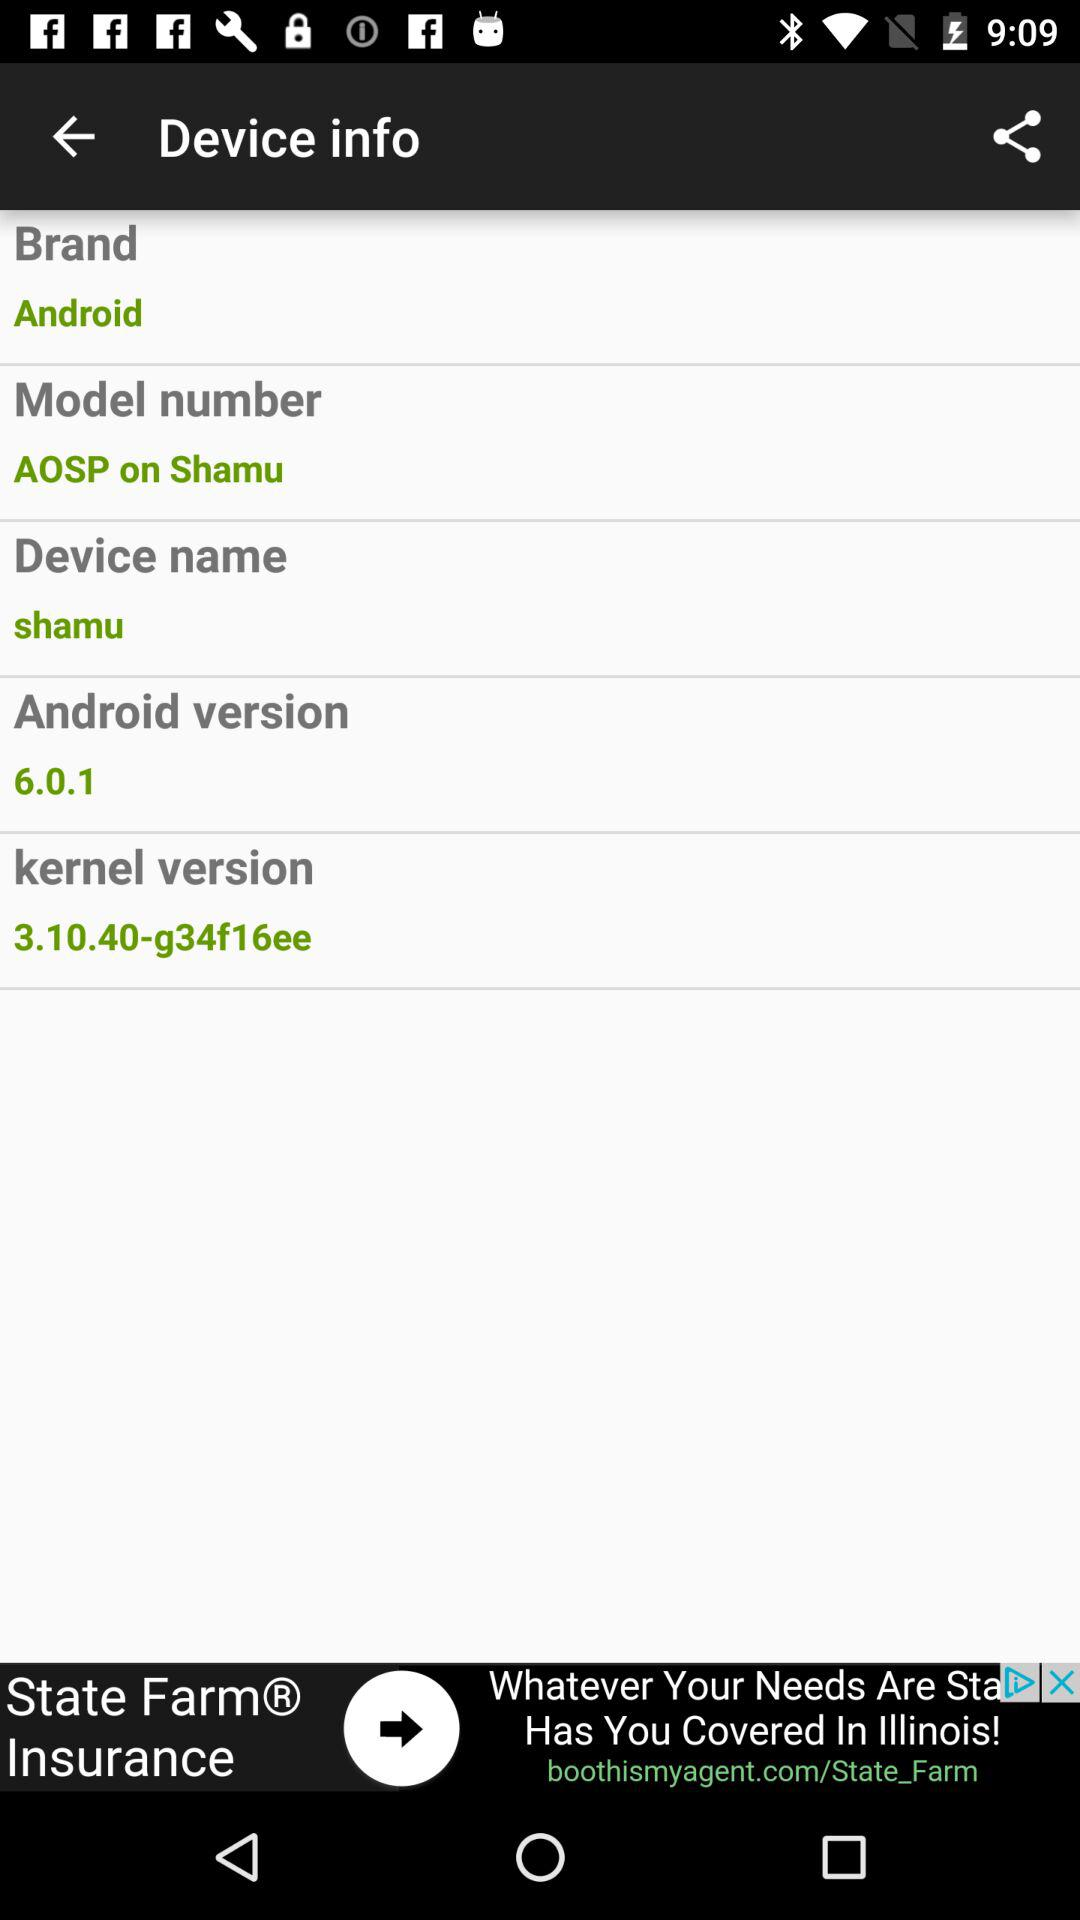What is the kernel version? The kernel version is 3.10.40-g34f16ee. 